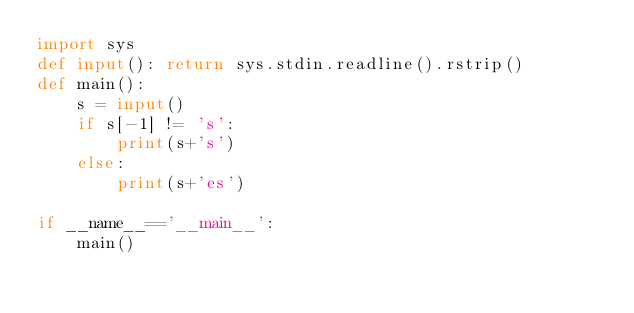Convert code to text. <code><loc_0><loc_0><loc_500><loc_500><_Python_>import sys
def input(): return sys.stdin.readline().rstrip()
def main():
    s = input()
    if s[-1] != 's':
        print(s+'s')
    else:
        print(s+'es')

if __name__=='__main__':
    main()</code> 